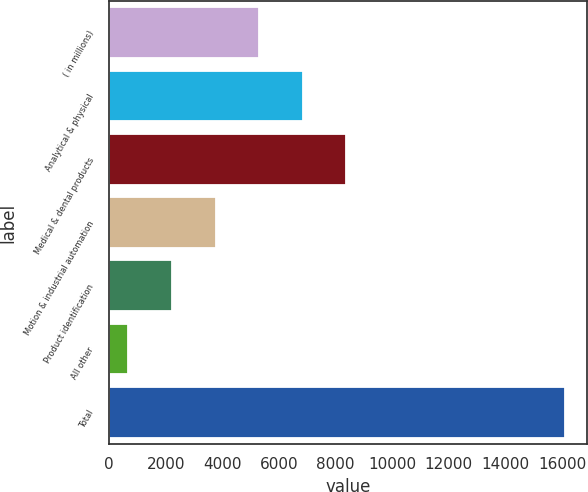<chart> <loc_0><loc_0><loc_500><loc_500><bar_chart><fcel>( in millions)<fcel>Analytical & physical<fcel>Medical & dental products<fcel>Motion & industrial automation<fcel>Product identification<fcel>All other<fcel>Total<nl><fcel>5300.98<fcel>6842.34<fcel>8383.7<fcel>3759.62<fcel>2218.26<fcel>676.9<fcel>16090.5<nl></chart> 